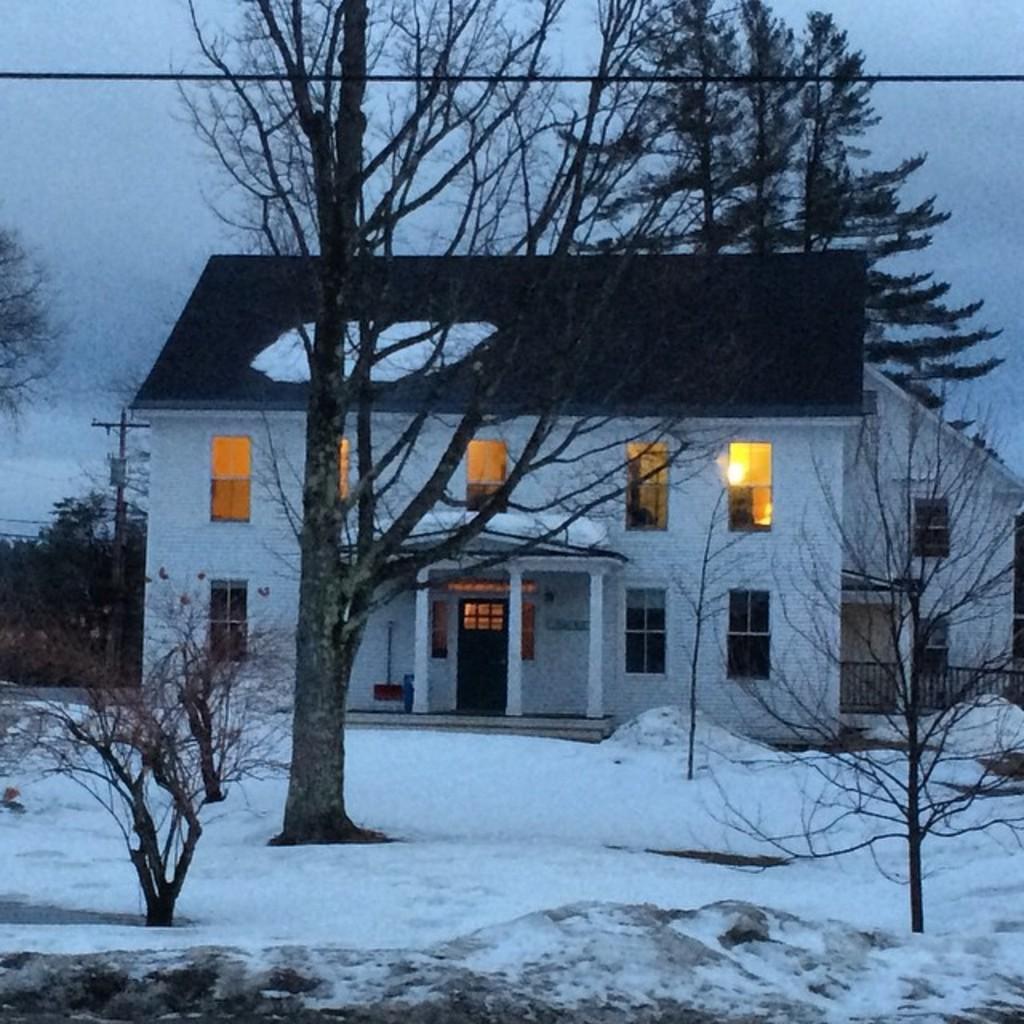Describe this image in one or two sentences. In this picture there is a building. On the bottom we can see plants and snow. On the left there is a electric pole and tress. At the top we can see sky and clouds. In the building we can see windows, doors, lights and cupboard. 